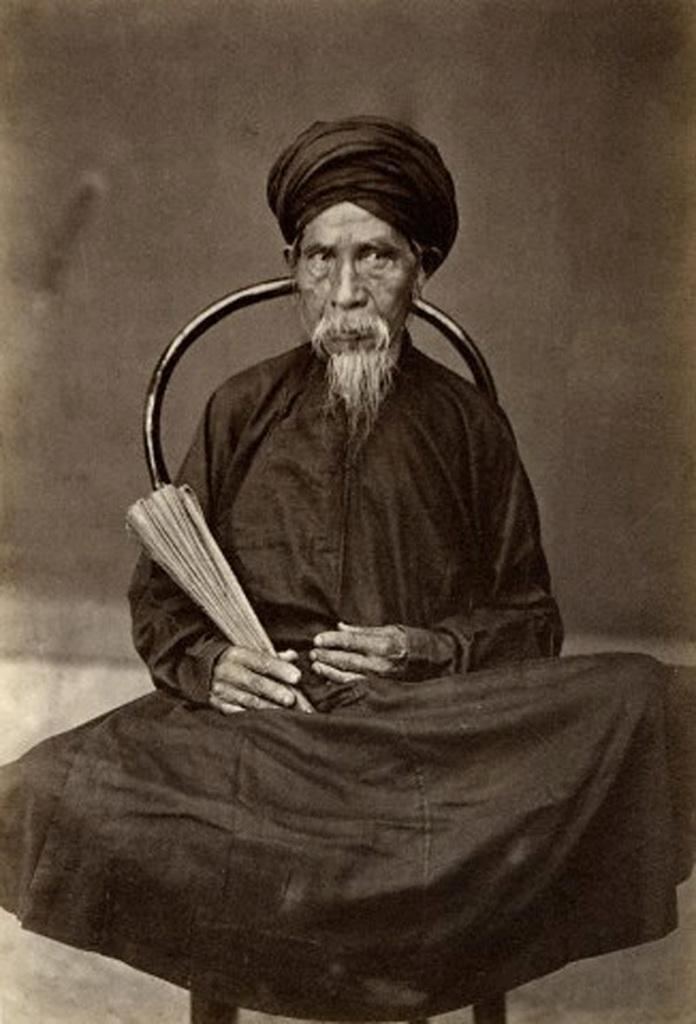What is the main subject of the image? The main subject of the image is an old photograph. What is shown in the photograph? The photograph depicts a person sitting in a chair. How many boats are visible in the image? There are no boats present in the image; it features an old photograph of a person sitting in a chair. 